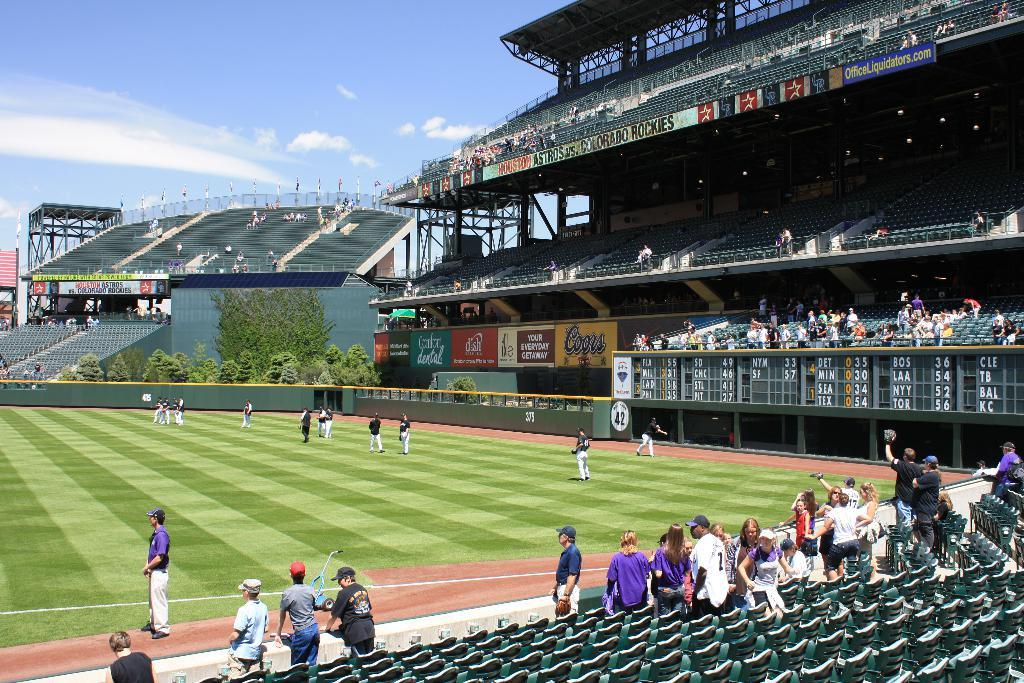Who or what can be seen in the image? There are people in the image. What objects are present for the people to sit on? There are chairs in the image. What can be seen in the distance behind the people? The background of the image includes a stadium, people, hoardings, trees, and the sky. What type of chain can be seen connecting the people in the image? There is no chain present in the image; it features people and chairs in a setting with a stadium and other background elements. 